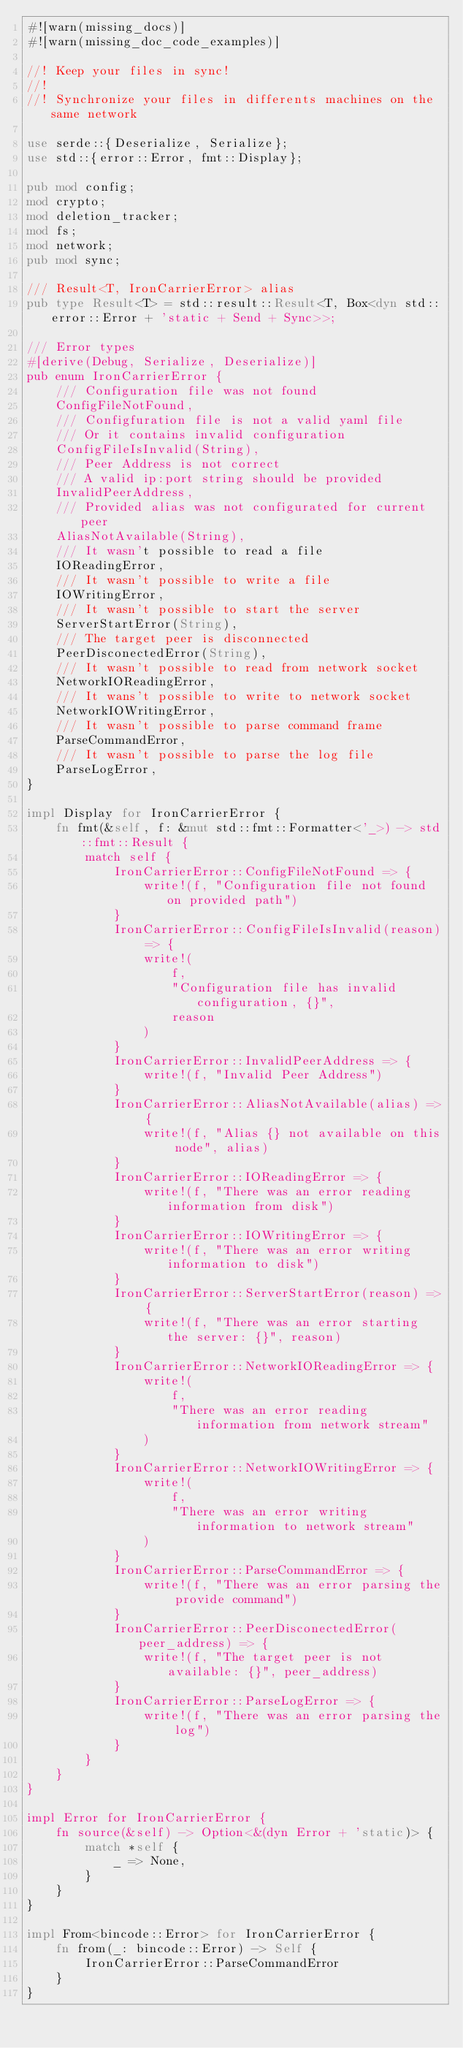<code> <loc_0><loc_0><loc_500><loc_500><_Rust_>#![warn(missing_docs)]
#![warn(missing_doc_code_examples)]

//! Keep your files in sync!
//!
//! Synchronize your files in differents machines on the same network

use serde::{Deserialize, Serialize};
use std::{error::Error, fmt::Display};

pub mod config;
mod crypto;
mod deletion_tracker;
mod fs;
mod network;
pub mod sync;

/// Result<T, IronCarrierError> alias
pub type Result<T> = std::result::Result<T, Box<dyn std::error::Error + 'static + Send + Sync>>;

/// Error types
#[derive(Debug, Serialize, Deserialize)]
pub enum IronCarrierError {
    /// Configuration file was not found
    ConfigFileNotFound,
    /// Configfuration file is not a valid yaml file  
    /// Or it contains invalid configuration
    ConfigFileIsInvalid(String),
    /// Peer Address is not correct  
    /// A valid ip:port string should be provided
    InvalidPeerAddress,
    /// Provided alias was not configurated for current peer
    AliasNotAvailable(String),
    /// It wasn't possible to read a file
    IOReadingError,
    /// It wasn't possible to write a file
    IOWritingError,
    /// It wasn't possible to start the server    
    ServerStartError(String),
    /// The target peer is disconnected
    PeerDisconectedError(String),
    /// It wasn't possible to read from network socket
    NetworkIOReadingError,
    /// It wans't possible to write to network socket
    NetworkIOWritingError,
    /// It wasn't possible to parse command frame
    ParseCommandError,
    /// It wasn't possible to parse the log file
    ParseLogError,
}

impl Display for IronCarrierError {
    fn fmt(&self, f: &mut std::fmt::Formatter<'_>) -> std::fmt::Result {
        match self {
            IronCarrierError::ConfigFileNotFound => {
                write!(f, "Configuration file not found on provided path")
            }
            IronCarrierError::ConfigFileIsInvalid(reason) => {
                write!(
                    f,
                    "Configuration file has invalid configuration, {}",
                    reason
                )
            }
            IronCarrierError::InvalidPeerAddress => {
                write!(f, "Invalid Peer Address")
            }
            IronCarrierError::AliasNotAvailable(alias) => {
                write!(f, "Alias {} not available on this node", alias)
            }
            IronCarrierError::IOReadingError => {
                write!(f, "There was an error reading information from disk")
            }
            IronCarrierError::IOWritingError => {
                write!(f, "There was an error writing information to disk")
            }
            IronCarrierError::ServerStartError(reason) => {
                write!(f, "There was an error starting the server: {}", reason)
            }
            IronCarrierError::NetworkIOReadingError => {
                write!(
                    f,
                    "There was an error reading information from network stream"
                )
            }
            IronCarrierError::NetworkIOWritingError => {
                write!(
                    f,
                    "There was an error writing information to network stream"
                )
            }
            IronCarrierError::ParseCommandError => {
                write!(f, "There was an error parsing the provide command")
            }
            IronCarrierError::PeerDisconectedError(peer_address) => {
                write!(f, "The target peer is not available: {}", peer_address)
            }
            IronCarrierError::ParseLogError => {
                write!(f, "There was an error parsing the log")
            }
        }
    }
}

impl Error for IronCarrierError {
    fn source(&self) -> Option<&(dyn Error + 'static)> {
        match *self {
            _ => None,
        }
    }
}

impl From<bincode::Error> for IronCarrierError {
    fn from(_: bincode::Error) -> Self {
        IronCarrierError::ParseCommandError
    }
}
</code> 